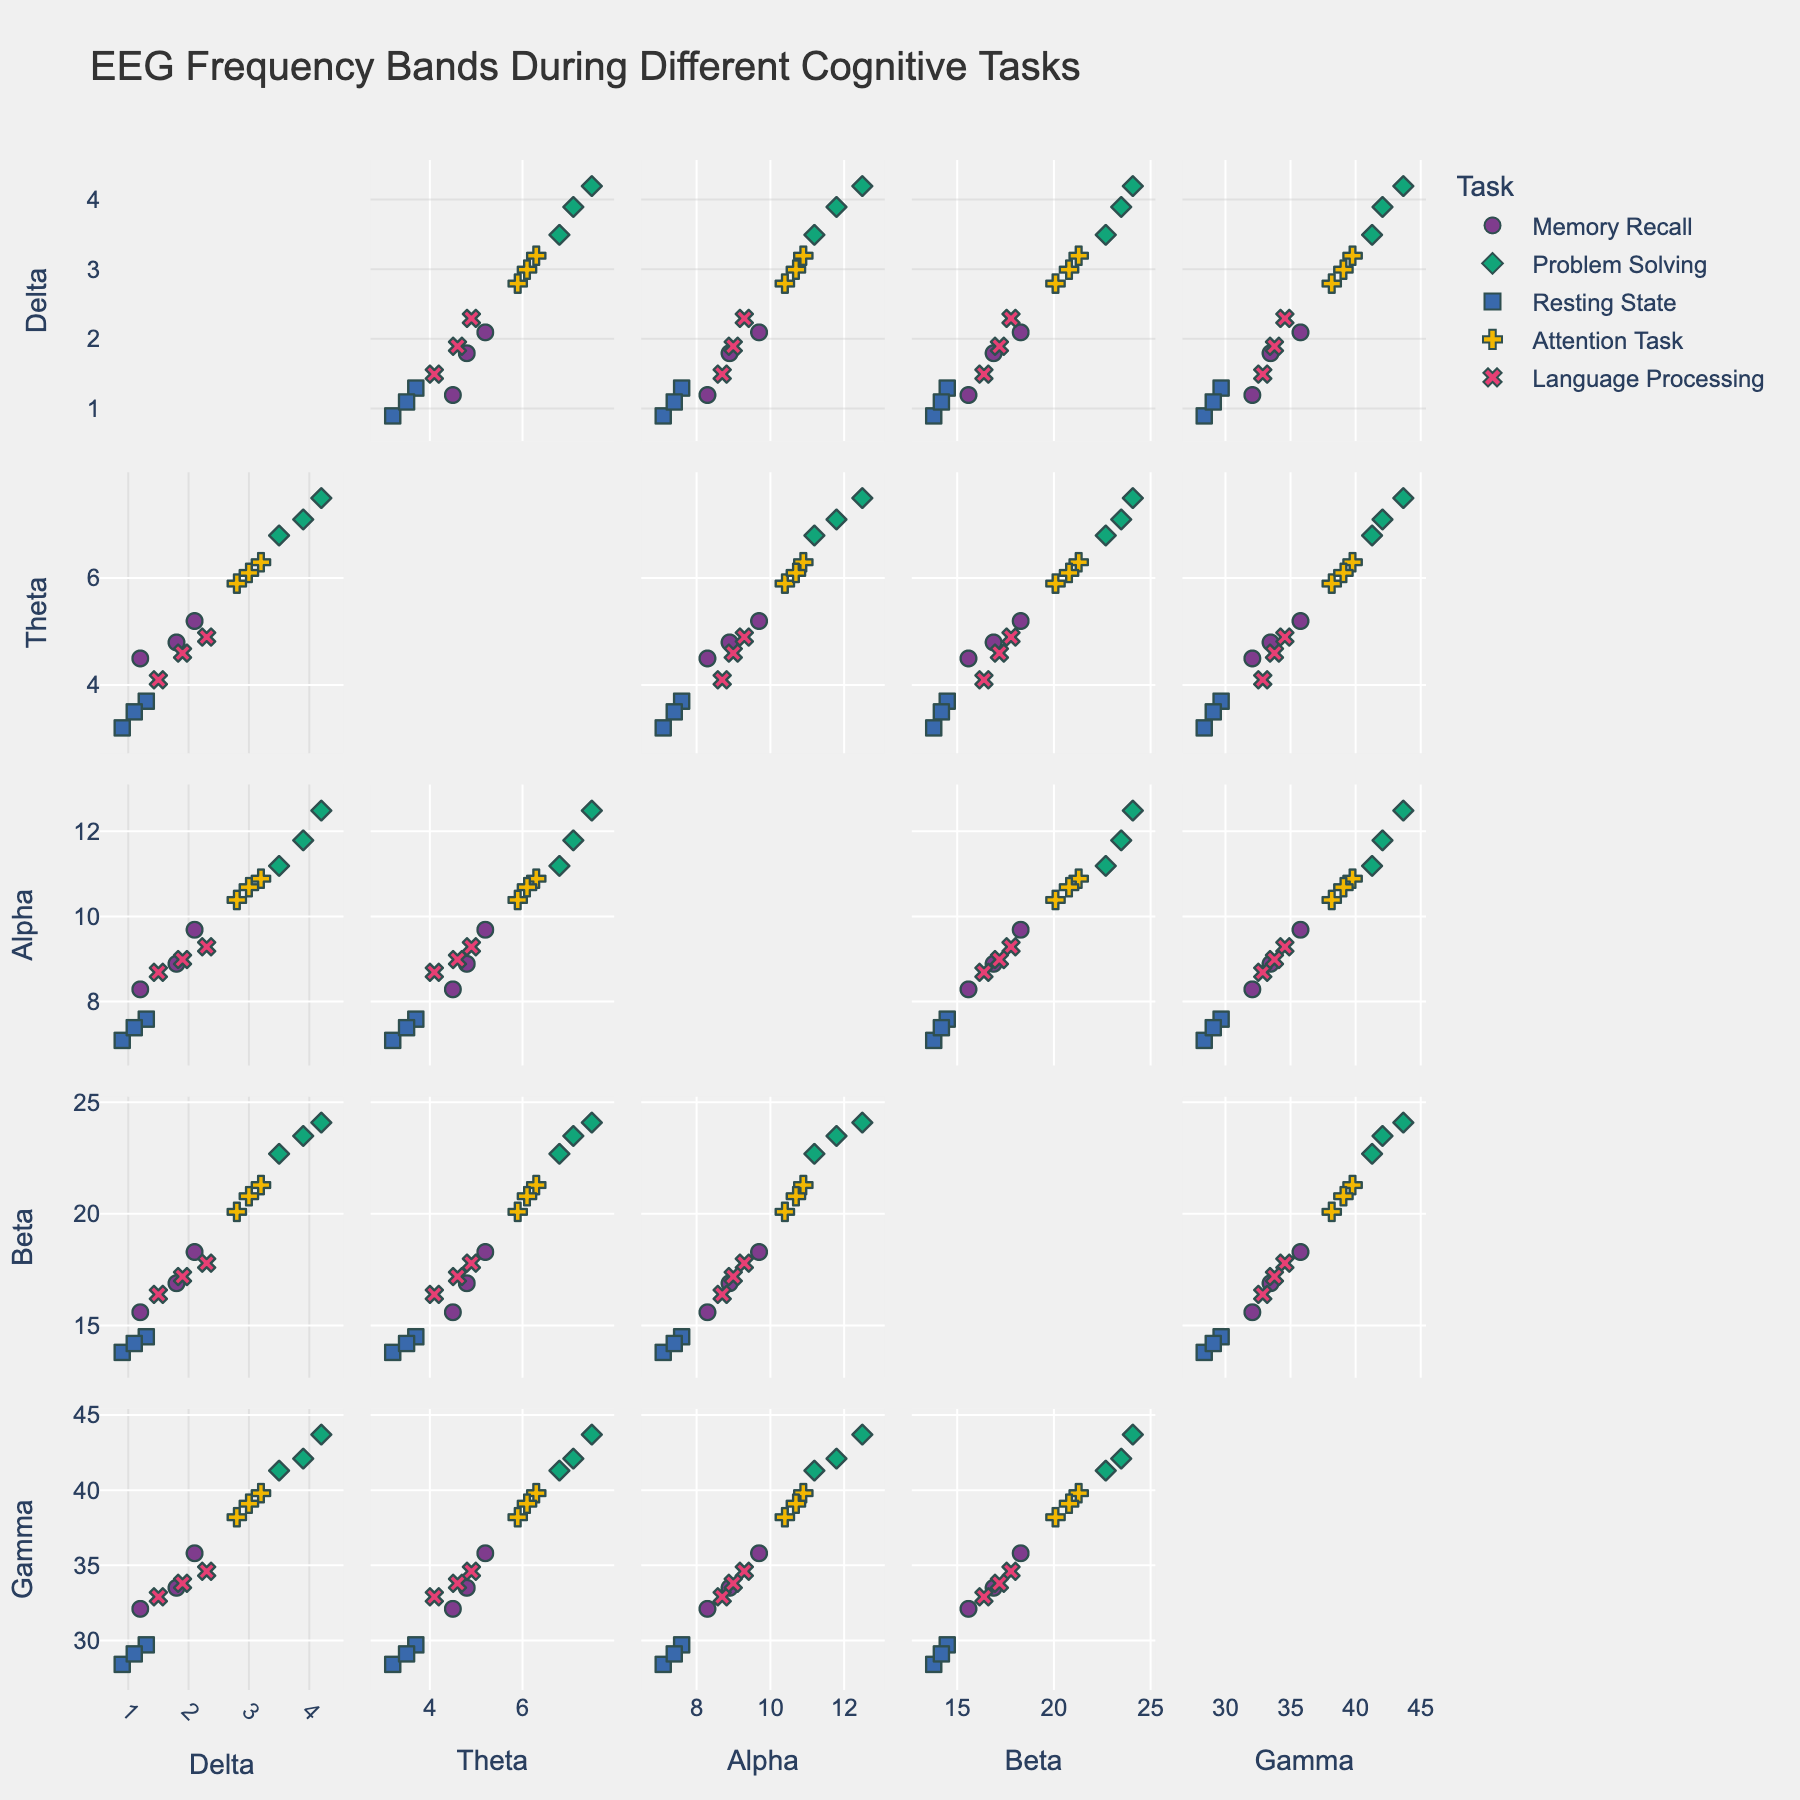What is the title of the figure? The title of the figure is displayed prominently at the top.
Answer: EEG Frequency Bands During Different Cognitive Tasks How many different cognitive tasks are represented in the figure? By looking at the legend or the symbols and colors assigned to different tasks, one can count the number of unique cognitive tasks.
Answer: 5 Which cognitive task has the highest Delta value? Identify the highest Delta value point on the Delta axis and check its corresponding cognitive task based on color or symbol.
Answer: Problem Solving What is the range of the Alpha values for the Resting State task? Identify the Alpha values for data points related to Resting State and determine the minimum and maximum values.
Answer: 7.1 to 7.6 Between which two tasks is the difference in average Gamma values the greatest? Calculate the average Gamma values for each task and compare them to identify the two tasks with the largest difference.
Answer: Problem Solving and Resting State Which task has the lowest Beta value and what is that value? Scan the Beta axis for the lowest value and identify its corresponding cognitive task.
Answer: Resting State, 13.8 Is there a visual trend between Beta and Gamma values for Problem Solving tasks? Observe the scatter plot of Beta vs. Gamma for Problem Solving points to determine if there is a visible trend.
Answer: Increasing trend Which two tasks seem to have the most similar spread of Theta values? Compare the spread or range of Theta values for the different tasks to identify the two most similar ones.
Answer: Memory Recall and Language Processing What is the average Alpha value for Memory Recall tasks? Sum the Alpha values for Memory Recall points and divide by the number of points.
Answer: 8.97 Which two EEG frequency bands show the highest correlation for Attention Task? Identify the scatter plots involving Attention Task and visually estimate which pair of EEG frequency bands has the most linear relationship.
Answer: Alpha and Gamma 